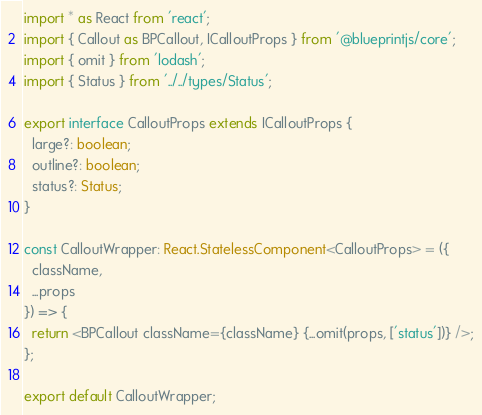Convert code to text. <code><loc_0><loc_0><loc_500><loc_500><_TypeScript_>import * as React from 'react';
import { Callout as BPCallout, ICalloutProps } from '@blueprintjs/core';
import { omit } from 'lodash';
import { Status } from '../../types/Status';

export interface CalloutProps extends ICalloutProps {
  large?: boolean;
  outline?: boolean;
  status?: Status;
}

const CalloutWrapper: React.StatelessComponent<CalloutProps> = ({
  className,
  ...props
}) => {
  return <BPCallout className={className} {...omit(props, ['status'])} />;
};

export default CalloutWrapper;
</code> 